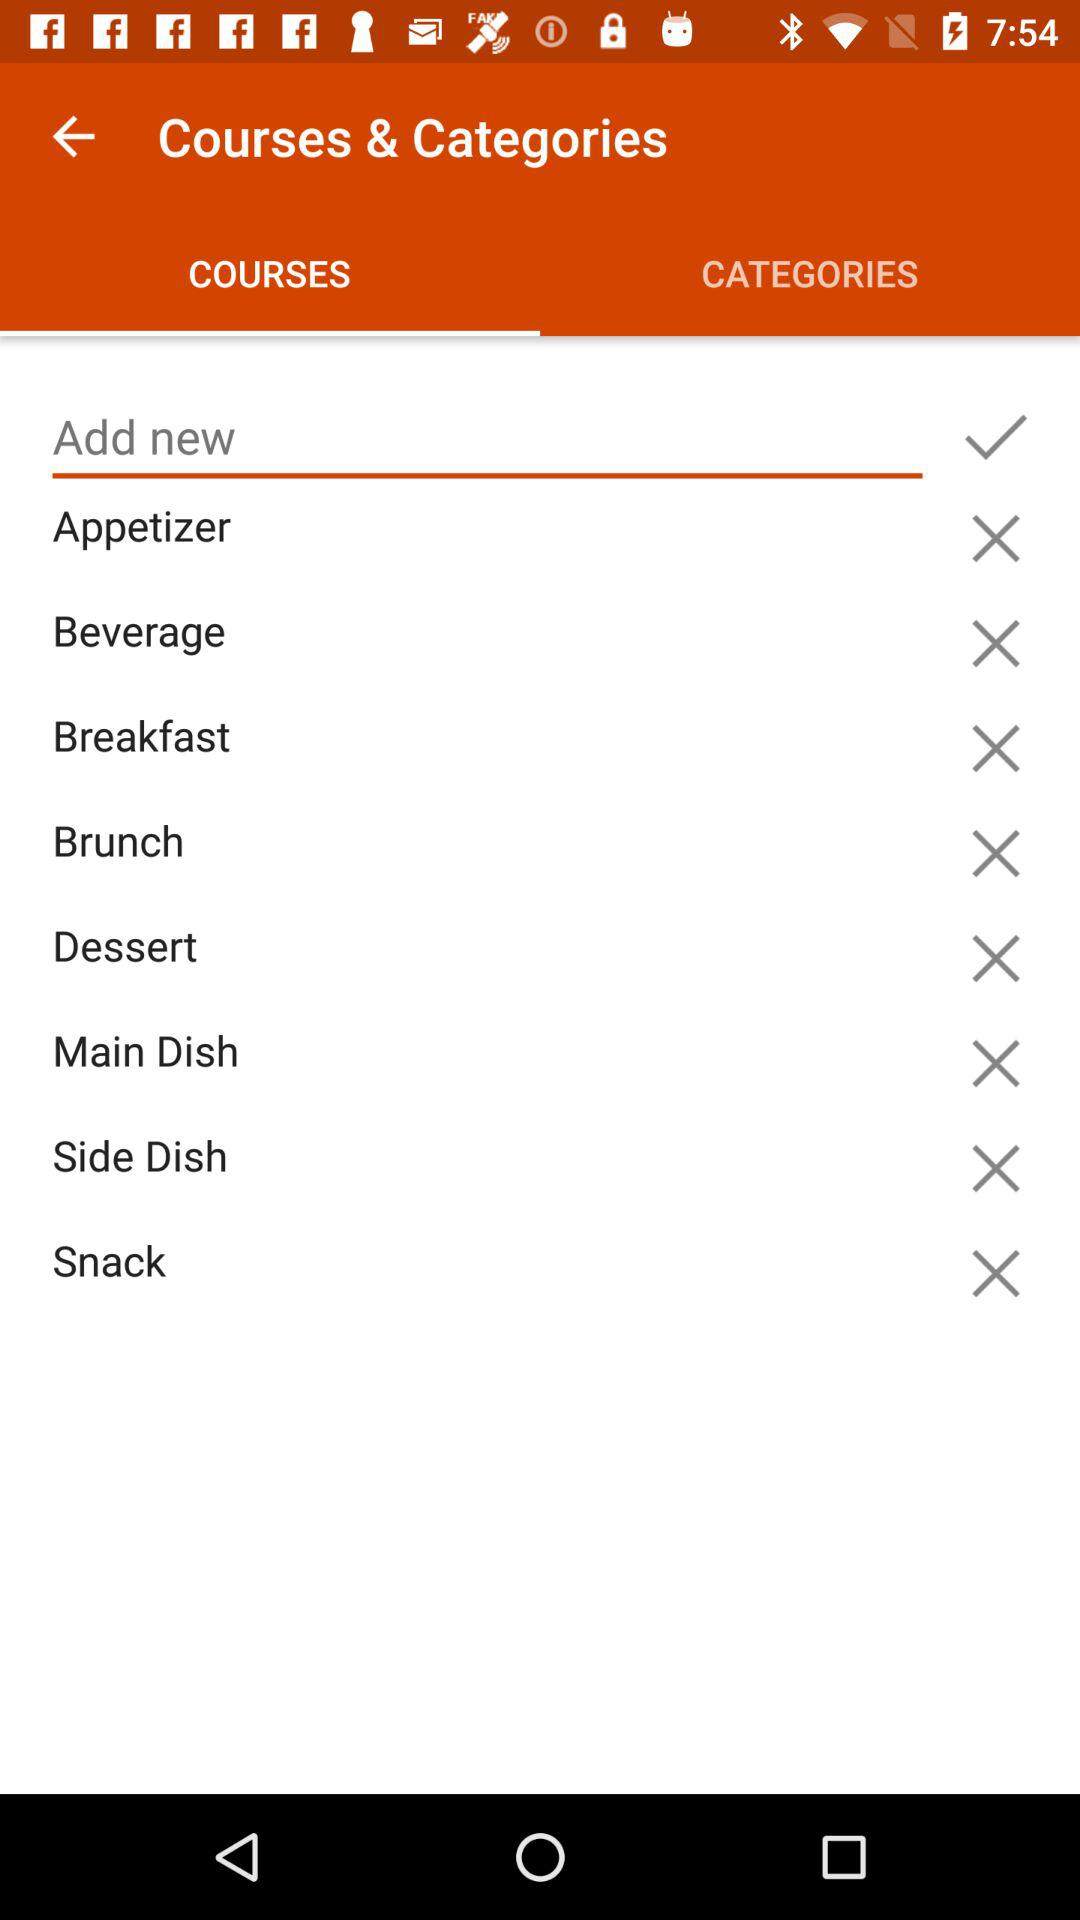How many categories have a check mark next to them?
Answer the question using a single word or phrase. 1 